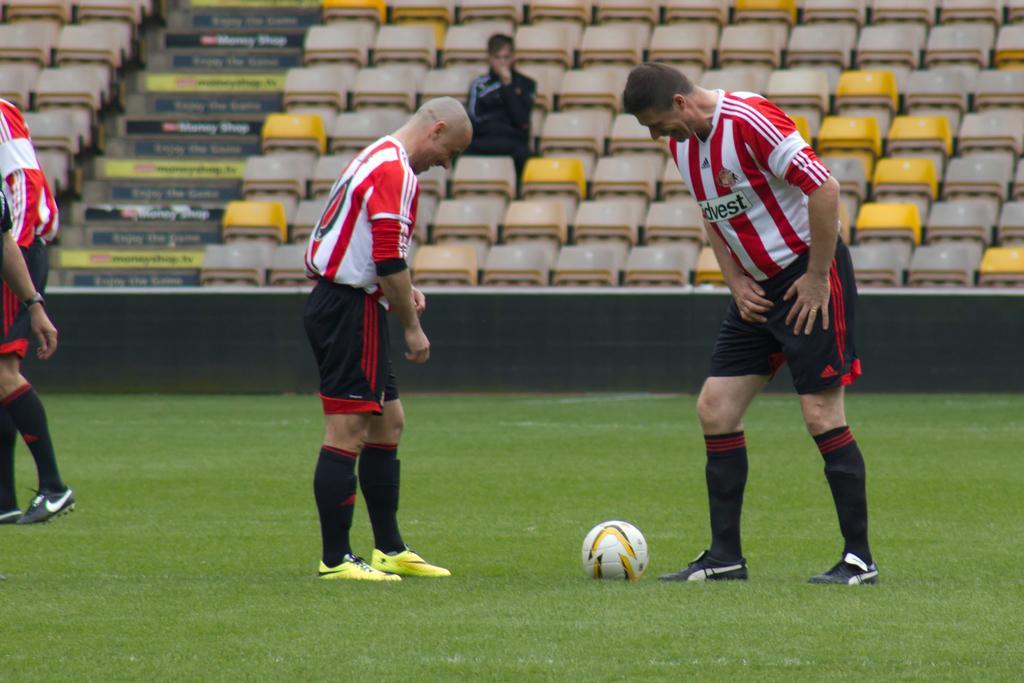In one or two sentences, can you explain what this image depicts? In this image I can see few persons wearing red, white and black colored dresses are standing and I can see a ball on the ground. In the background I can see number of chairs in the stadium, few stairs and a person sitting on a chair. 